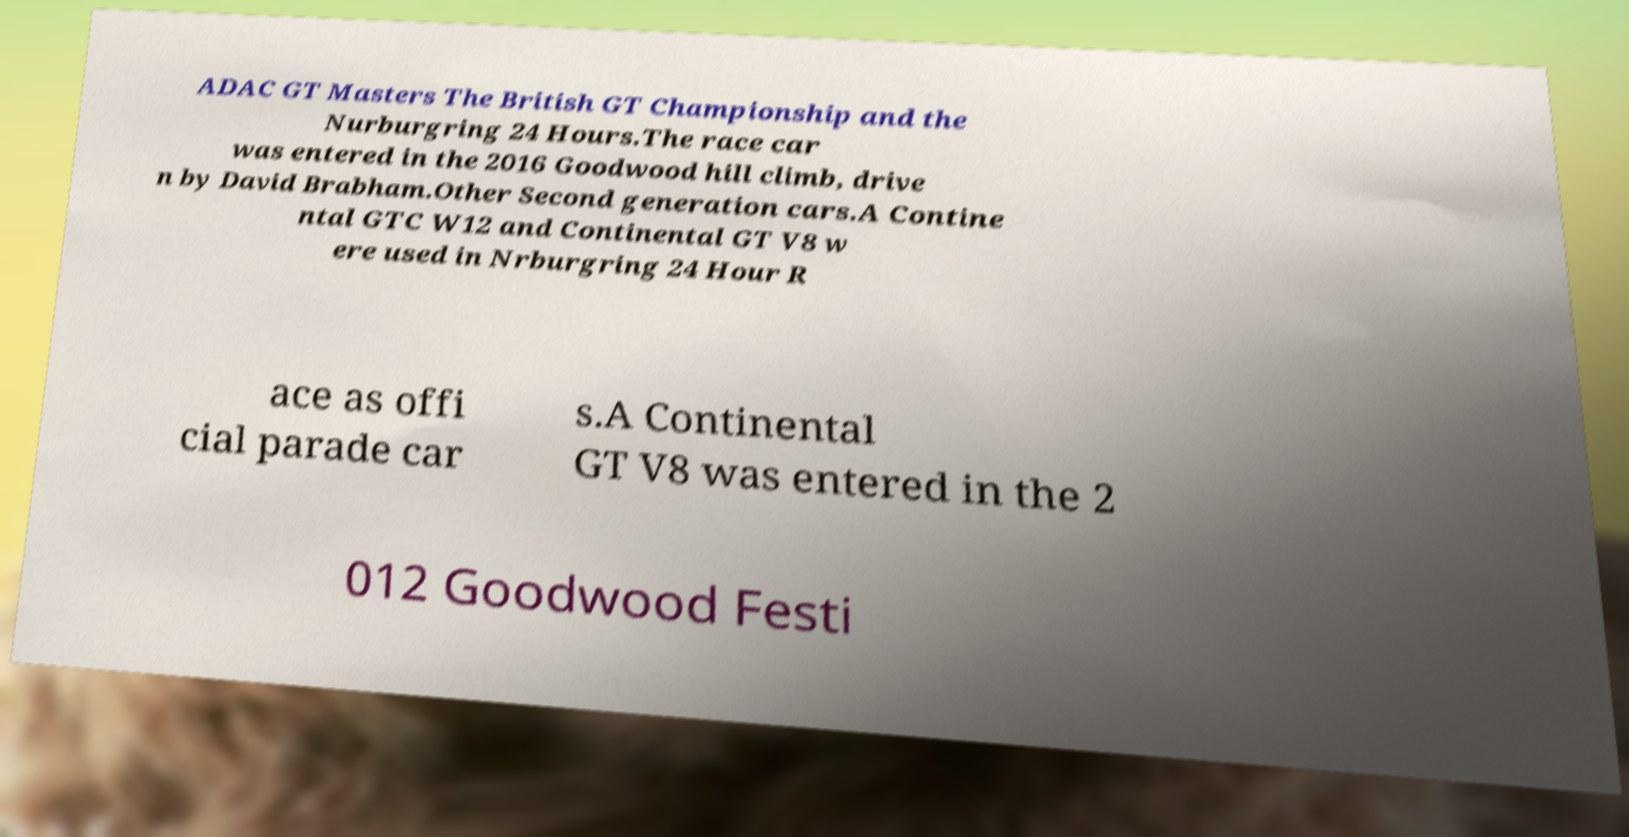Could you extract and type out the text from this image? ADAC GT Masters The British GT Championship and the Nurburgring 24 Hours.The race car was entered in the 2016 Goodwood hill climb, drive n by David Brabham.Other Second generation cars.A Contine ntal GTC W12 and Continental GT V8 w ere used in Nrburgring 24 Hour R ace as offi cial parade car s.A Continental GT V8 was entered in the 2 012 Goodwood Festi 